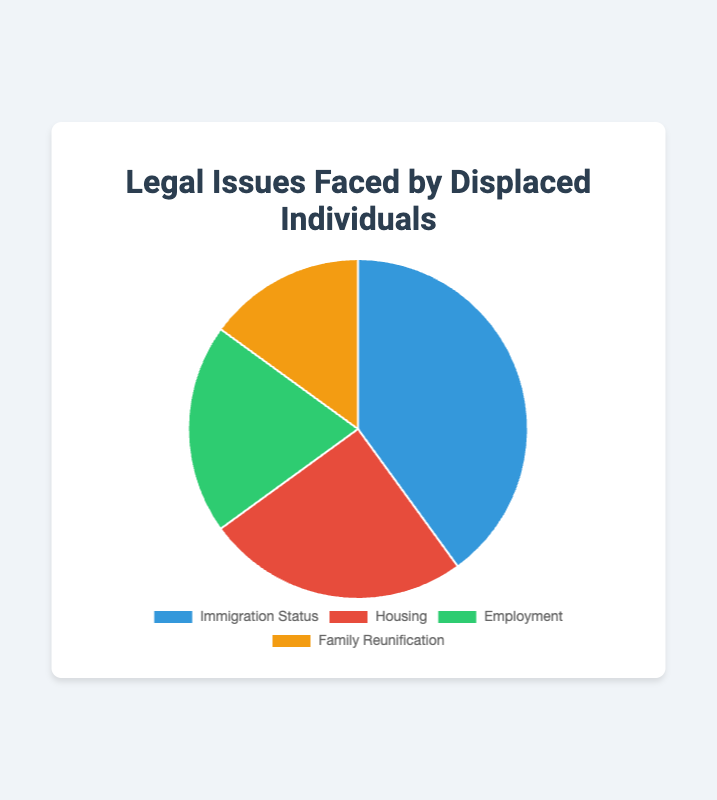Which type of legal issue is faced by the largest percentage of displaced individuals? Immigration Status is the largest segment in the pie chart, representing 40%, which is the highest percentage among the categories.
Answer: Immigration Status Which two types of legal issues, when combined, account for over half of the total percentage? Combining 'Immigration Status' (40%) and 'Housing' (25%) results in 65%, which is more than 50%.
Answer: Immigration Status and Housing How much greater is the percentage of displaced individuals facing issues with immigration status compared to family reunification? The percentage facing immigration status issues is 40%, and family reunification is 15%. The difference is 40% - 15% = 25%.
Answer: 25% What percentage of the total issues is accounted for by employment and family reunification combined? Employment accounts for 20%, and family reunification accounts for 15%. Together, they make up 20% + 15% = 35% of the total.
Answer: 35% Which category is represented by the green segment of the pie chart? The color green represents 'Employment' in the pie chart.
Answer: Employment Do housing-related issues or employment-related issues have a higher percentage? Housing-related issues have a higher percentage (25%) compared to employment-related issues (20%).
Answer: Housing What is the average percentage of the four types of legal issues faced by displaced individuals? Summing the percentages (40% + 25% + 20% + 15%) gives 100%. Dividing by the number of categories (4) results in an average of 100% / 4 = 25%.
Answer: 25% What is the difference between the highest and lowest percentages in the chart? The highest percentage is 40% (Immigration Status) and the lowest is 15% (Family Reunification). The difference is 40% - 15% = 25%.
Answer: 25% What fraction of the total percentage do housing and family reunification issues represent combined? Housing accounts for 25% and family reunification accounts for 15%. Combined, they account for 25% + 15% = 40%. As a fraction of the total 100%, this is 40/100, which simplifies to 2/5.
Answer: 2/5 